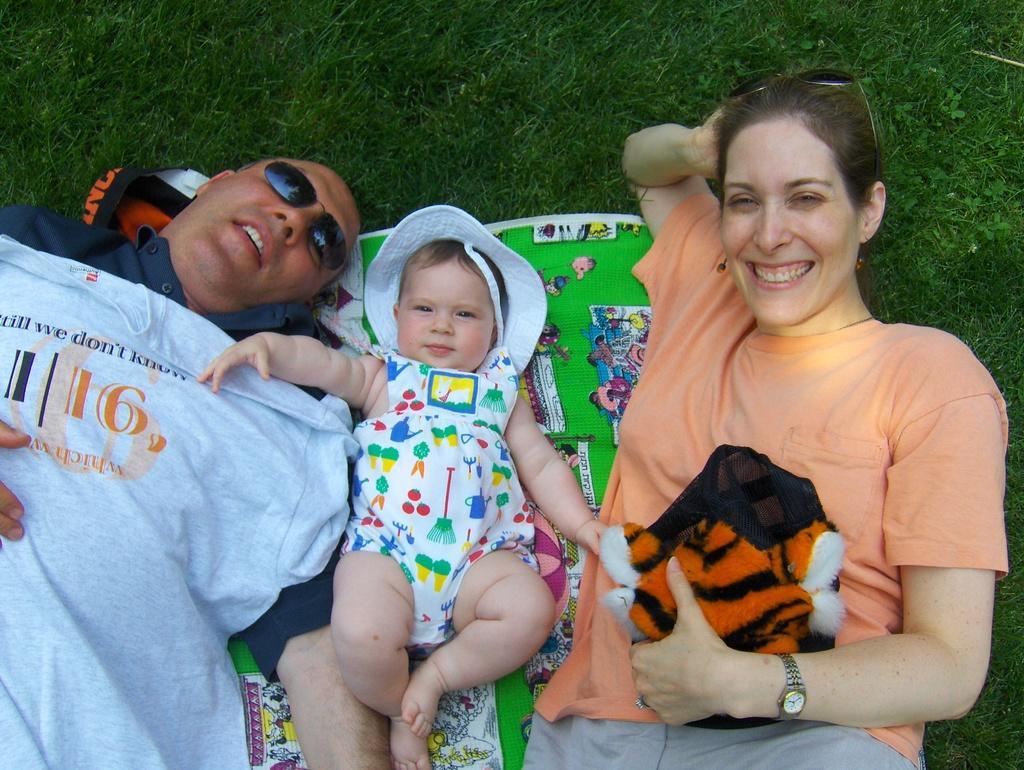Can you describe this image briefly? In this image, we can see two people and baby are laying on a mat. Woman and baby are seeing and smiling. Woman is holding some toy. Left side of the image, a man is wearing glasses. Top of the image, we can see a grass. 